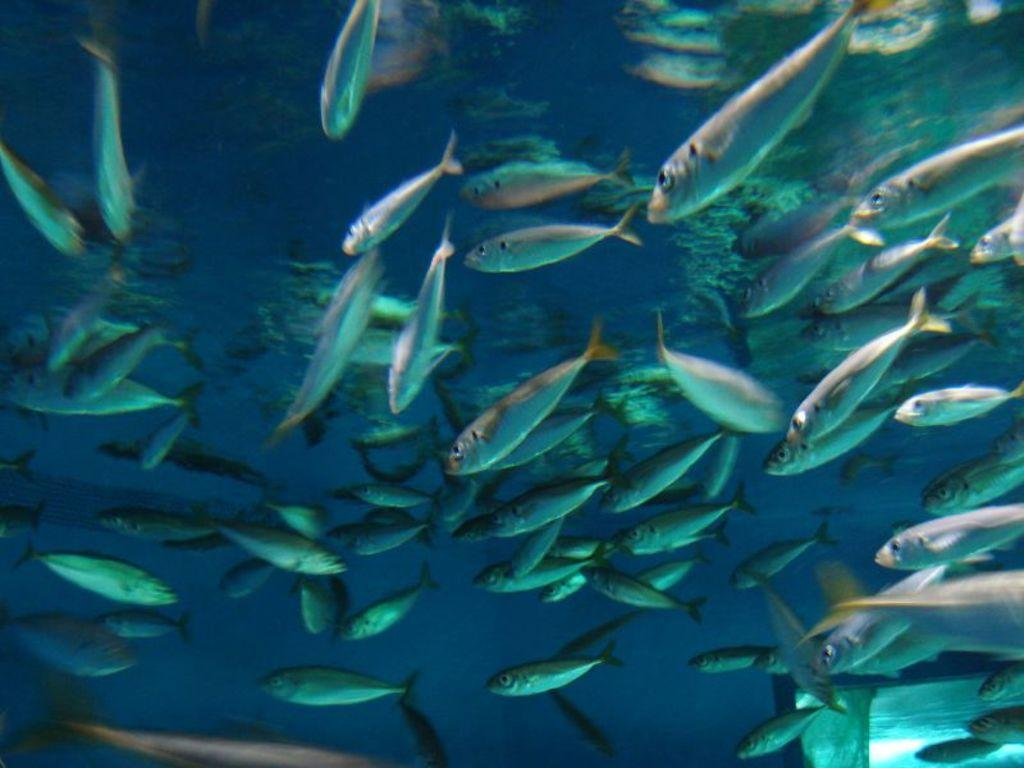What type of animals are in the image? There are fishes in the image. Where are the fishes located? The fishes are in the water. What type of wool is being used by the slave in the image? There is no slave or wool present in the image; it features fishes in the water. What type of quill is being used by the fishes in the image? There is no quill present in the image; the fishes are in the water and do not use writing instruments. 